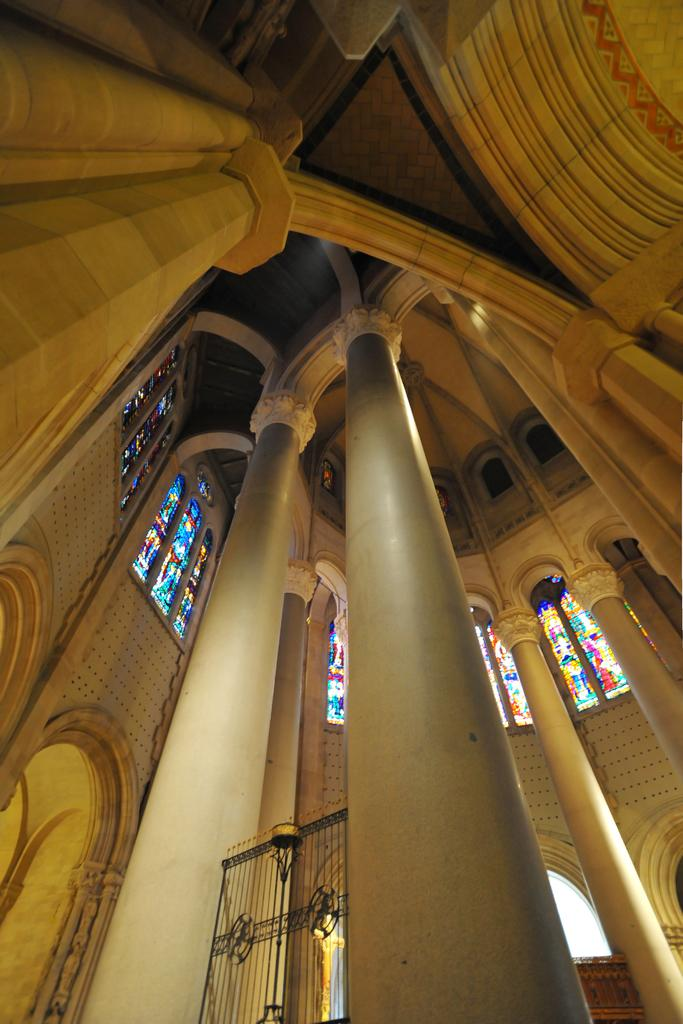Where was the image taken? The image was taken inside a building. What architectural features can be seen in the image? There are pillars, windows, and a wall visible in the image. What type of entrance is present in the image? There is a black gate in the image. Can you see any leaves falling from the trees in the image? There are no trees or leaves present in the image, as it was taken inside a building. 